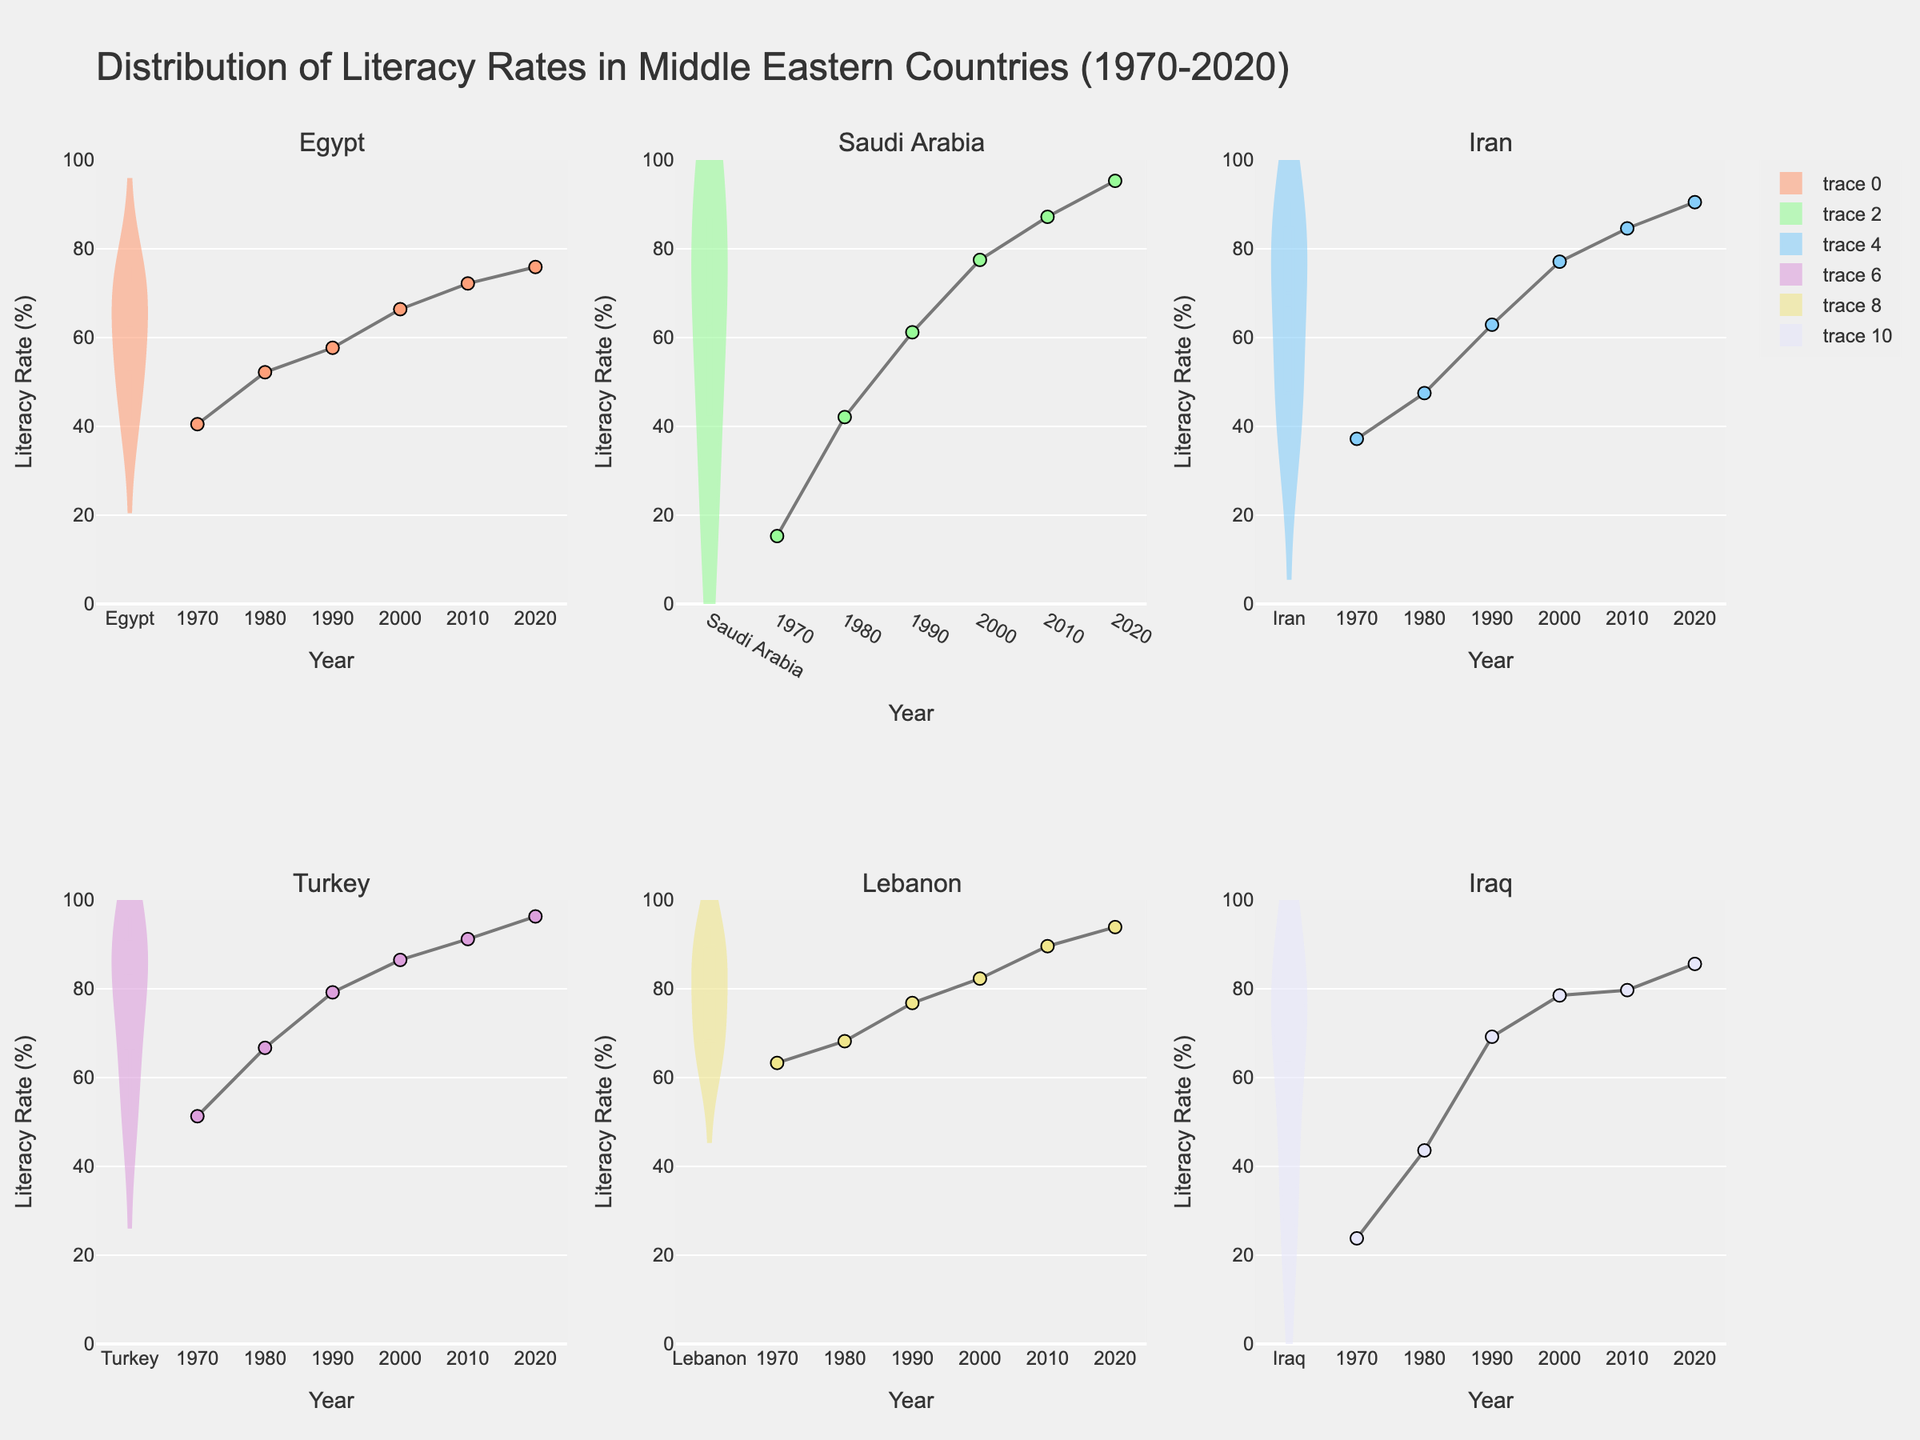What is the title of the figure? The title of the figure is placed at the top and usually provides context and overall information about the data displayed in the plot.
Answer: Distribution of Literacy Rates in Middle Eastern Countries (1970-2020) Which country's literacy rate reached the highest value in 2020? For each plotted country's literacy rate over the years, the highest literacy rate value in 2020 can be seen on each subplot.
Answer: Turkey How does the median literacy rate of Iran compare to that of Egypt? The median literacy rate is typically indicated by a line inside each violin plot. You would compare the position of these lines for Iran and Egypt.
Answer: Iran's median literacy rate is higher than Egypt's What range of years does the figure cover? The x-axes of the subplots indicate the range of years for which the literacy rates are provided.
Answer: 1970-2020 During which decade did Saudi Arabia see the most significant increase in literacy rates? By looking at the trend lines in the scatter plots within the violin plots, observe the steepest slope indicating the most significant increase.
Answer: 1970-1980 Which countries have achieved a literacy rate of over 90% by 2020? By checking the maximum values in each subplot's scatter plot for the year 2020 (the latest year), identify which exceed 90%.
Answer: Saudi Arabia, Iran, Turkey, Lebanon What is the overall trend in literacy rates for the countries displayed? The trend lines in the scatter plots within the violin plots can be observed to determine if there is an overall increase, decrease or stable trend over the years.
Answer: Increasing trend Are there any countries with significant outliers in their literacy rates? Outliers can be visually identified as points that are far from the rest of the data within each violin plot.
Answer: No significant outliers Which country had the lowest literacy rate in 1970? By observing the lowest point of the scatter data in 1970 across all subplots, determine the country with the minimum value.
Answer: Saudi Arabia Compare the mean literacy rates for Iraq and Lebanon. The mean literacy rate can be inferred from the meanline visible in each violin plot. Compare the positions of these lines for Iraq and Lebanon.
Answer: Lebanon's mean literacy rate is higher than Iraq's 